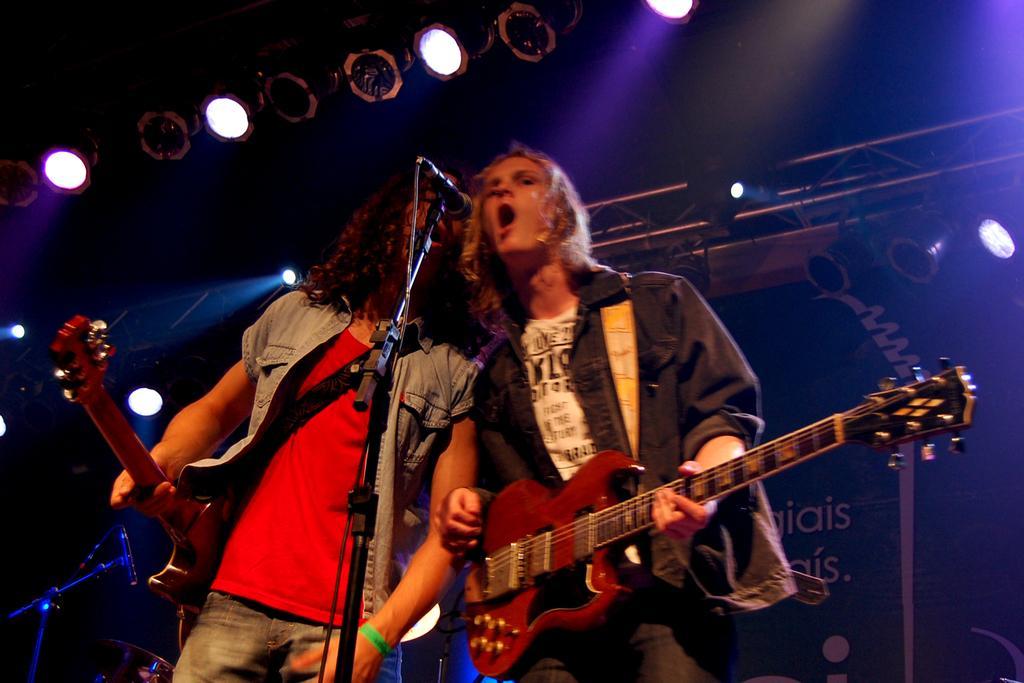Could you give a brief overview of what you see in this image? This picture is clicked at a concert. There are two women in the image singing. There is a microphone and microphone stand in front of them. They are wearing guitars. both of them are wearing blue jackets. In the background there is banner and text on it and spotlights too. 